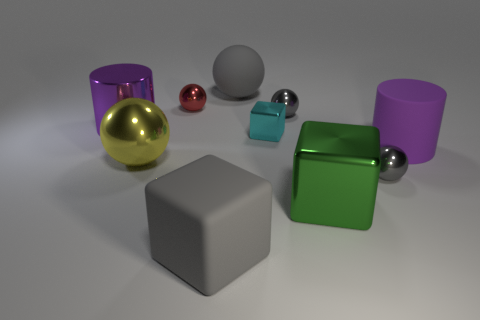Does the large metal cylinder have the same color as the cylinder that is right of the tiny metal cube?
Provide a short and direct response. Yes. Is there another cylinder that has the same color as the big metal cylinder?
Offer a very short reply. Yes. What material is the big object that is the same color as the rubber sphere?
Your answer should be compact. Rubber. How many cyan objects are either big matte cylinders or small objects?
Provide a short and direct response. 1. Is the number of small purple spheres greater than the number of big gray balls?
Provide a short and direct response. No. Is the small metal cube the same color as the matte cylinder?
Keep it short and to the point. No. How many things are large yellow rubber cubes or things that are in front of the large matte ball?
Your answer should be very brief. 9. How many other objects are the same shape as the yellow metal object?
Your answer should be compact. 4. Are there fewer small balls behind the tiny red sphere than gray shiny things behind the yellow metal object?
Provide a succinct answer. Yes. There is a tiny red object that is made of the same material as the cyan block; what is its shape?
Provide a succinct answer. Sphere. 